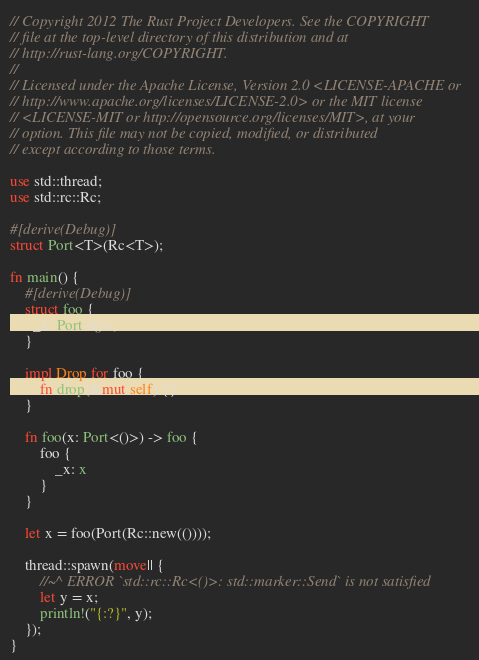<code> <loc_0><loc_0><loc_500><loc_500><_Rust_>// Copyright 2012 The Rust Project Developers. See the COPYRIGHT
// file at the top-level directory of this distribution and at
// http://rust-lang.org/COPYRIGHT.
//
// Licensed under the Apache License, Version 2.0 <LICENSE-APACHE or
// http://www.apache.org/licenses/LICENSE-2.0> or the MIT license
// <LICENSE-MIT or http://opensource.org/licenses/MIT>, at your
// option. This file may not be copied, modified, or distributed
// except according to those terms.

use std::thread;
use std::rc::Rc;

#[derive(Debug)]
struct Port<T>(Rc<T>);

fn main() {
    #[derive(Debug)]
    struct foo {
      _x: Port<()>,
    }

    impl Drop for foo {
        fn drop(&mut self) {}
    }

    fn foo(x: Port<()>) -> foo {
        foo {
            _x: x
        }
    }

    let x = foo(Port(Rc::new(())));

    thread::spawn(move|| {
        //~^ ERROR `std::rc::Rc<()>: std::marker::Send` is not satisfied
        let y = x;
        println!("{:?}", y);
    });
}
</code> 